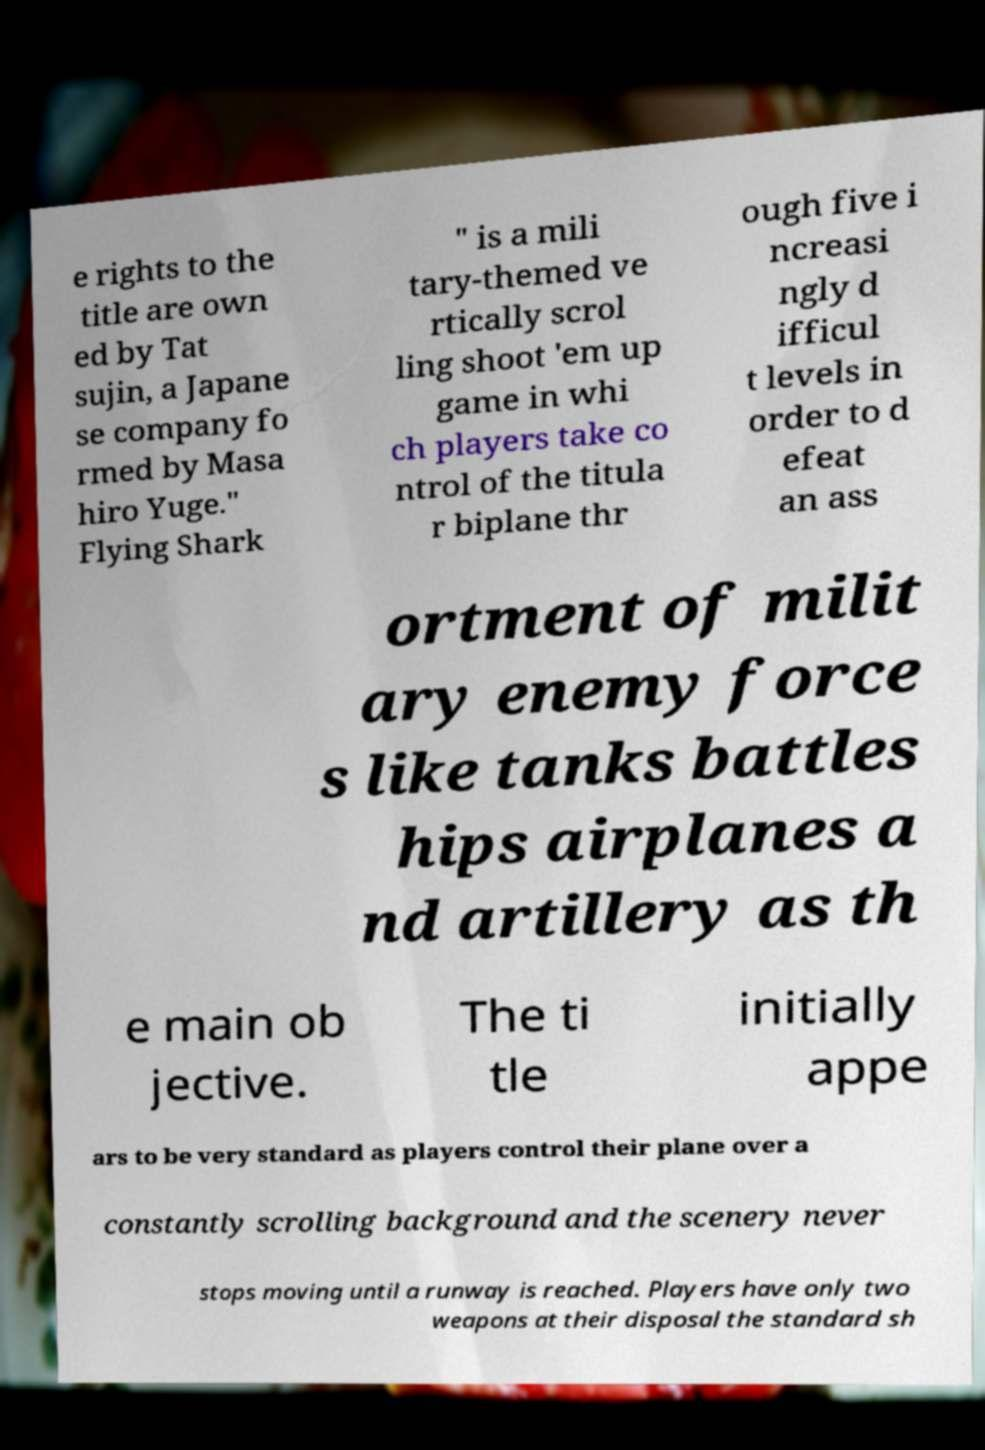I need the written content from this picture converted into text. Can you do that? e rights to the title are own ed by Tat sujin, a Japane se company fo rmed by Masa hiro Yuge." Flying Shark " is a mili tary-themed ve rtically scrol ling shoot 'em up game in whi ch players take co ntrol of the titula r biplane thr ough five i ncreasi ngly d ifficul t levels in order to d efeat an ass ortment of milit ary enemy force s like tanks battles hips airplanes a nd artillery as th e main ob jective. The ti tle initially appe ars to be very standard as players control their plane over a constantly scrolling background and the scenery never stops moving until a runway is reached. Players have only two weapons at their disposal the standard sh 